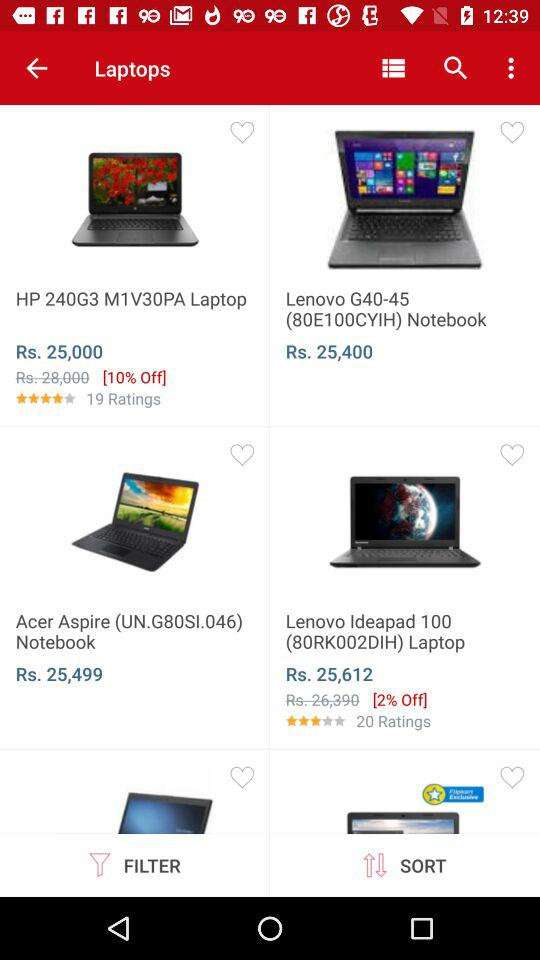What is the discounted price of the "HP 240G3 M1V30PA Laptop"? The discounted price of the "HP 240G3 M1V30PA Laptop" is ₹25000. 